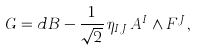<formula> <loc_0><loc_0><loc_500><loc_500>G = d B - \frac { 1 } { \sqrt { 2 } } \, \eta _ { I J } \, A ^ { I } \wedge F ^ { J } ,</formula> 